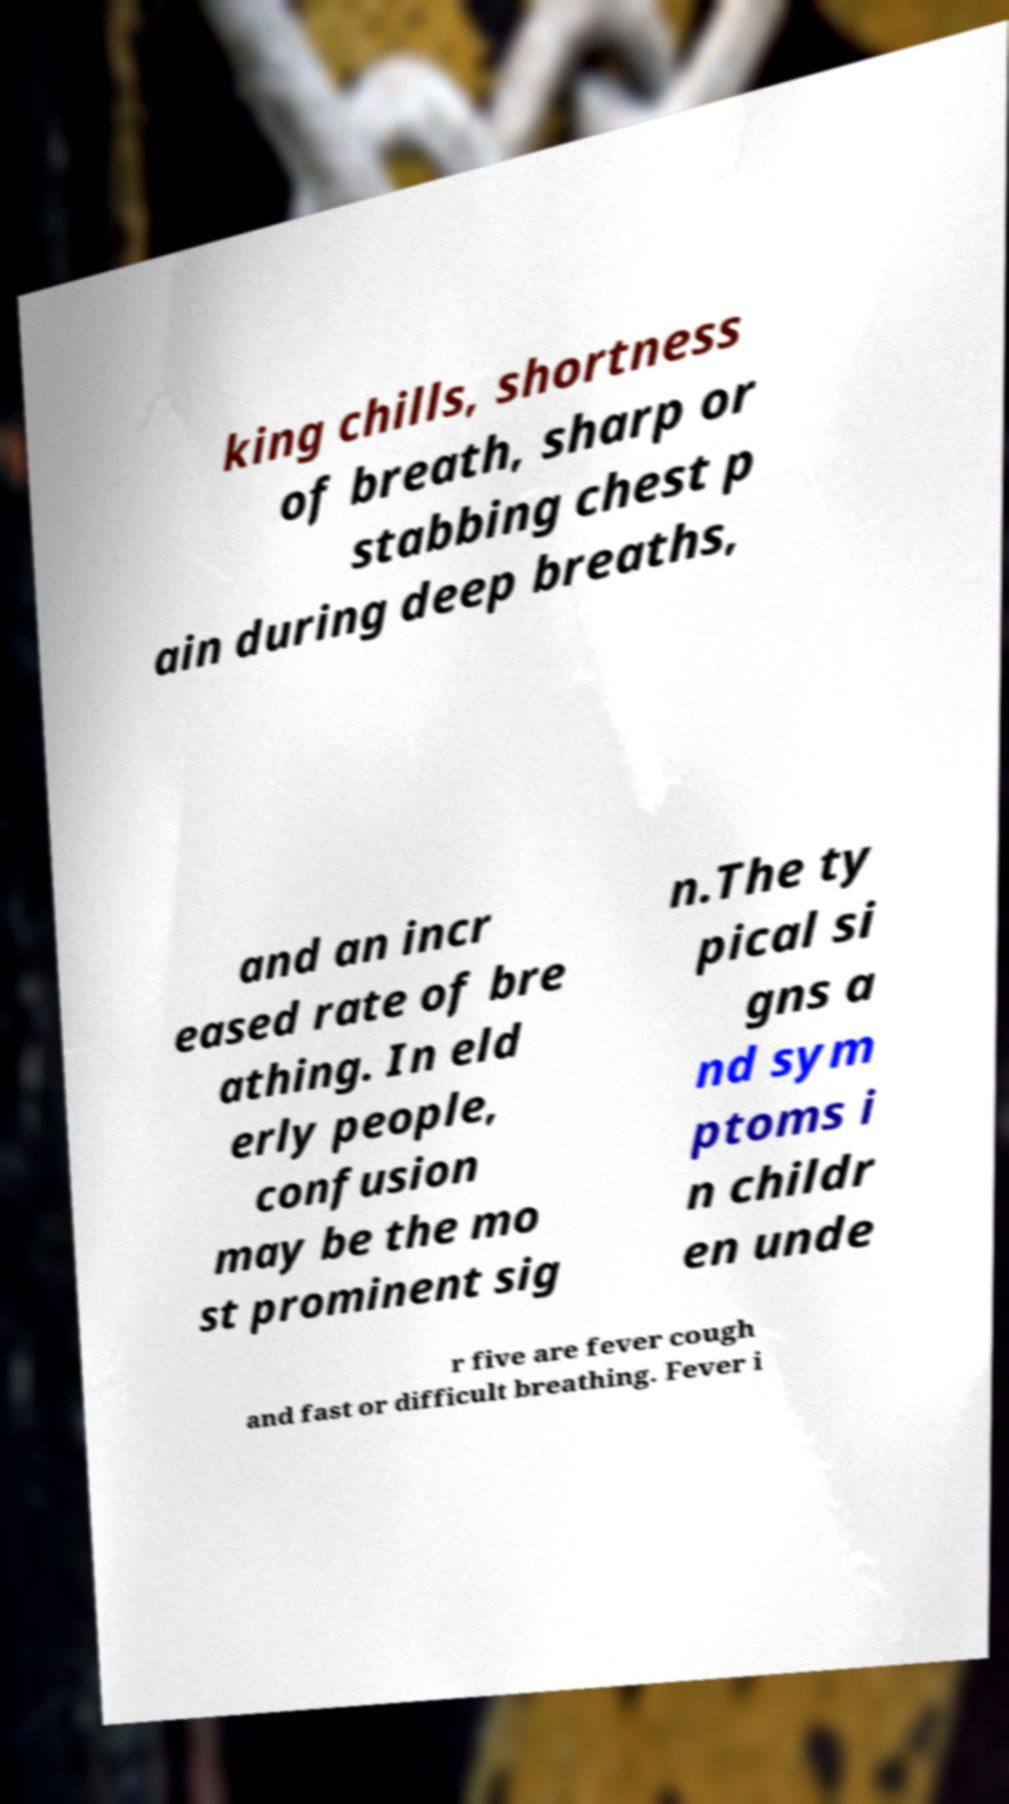For documentation purposes, I need the text within this image transcribed. Could you provide that? king chills, shortness of breath, sharp or stabbing chest p ain during deep breaths, and an incr eased rate of bre athing. In eld erly people, confusion may be the mo st prominent sig n.The ty pical si gns a nd sym ptoms i n childr en unde r five are fever cough and fast or difficult breathing. Fever i 